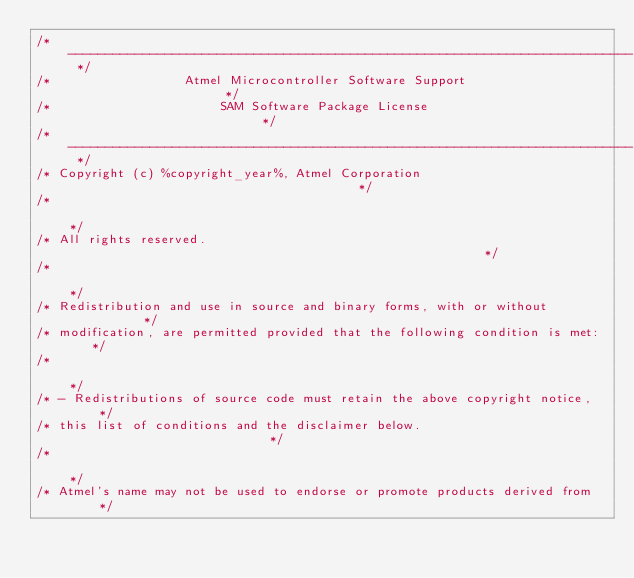<code> <loc_0><loc_0><loc_500><loc_500><_C_>/* ---------------------------------------------------------------------------- */
/*                  Atmel Microcontroller Software Support                      */
/*                       SAM Software Package License                           */
/* ---------------------------------------------------------------------------- */
/* Copyright (c) %copyright_year%, Atmel Corporation                                        */
/*                                                                              */
/* All rights reserved.                                                         */
/*                                                                              */
/* Redistribution and use in source and binary forms, with or without           */
/* modification, are permitted provided that the following condition is met:    */
/*                                                                              */
/* - Redistributions of source code must retain the above copyright notice,     */
/* this list of conditions and the disclaimer below.                            */
/*                                                                              */
/* Atmel's name may not be used to endorse or promote products derived from     */</code> 